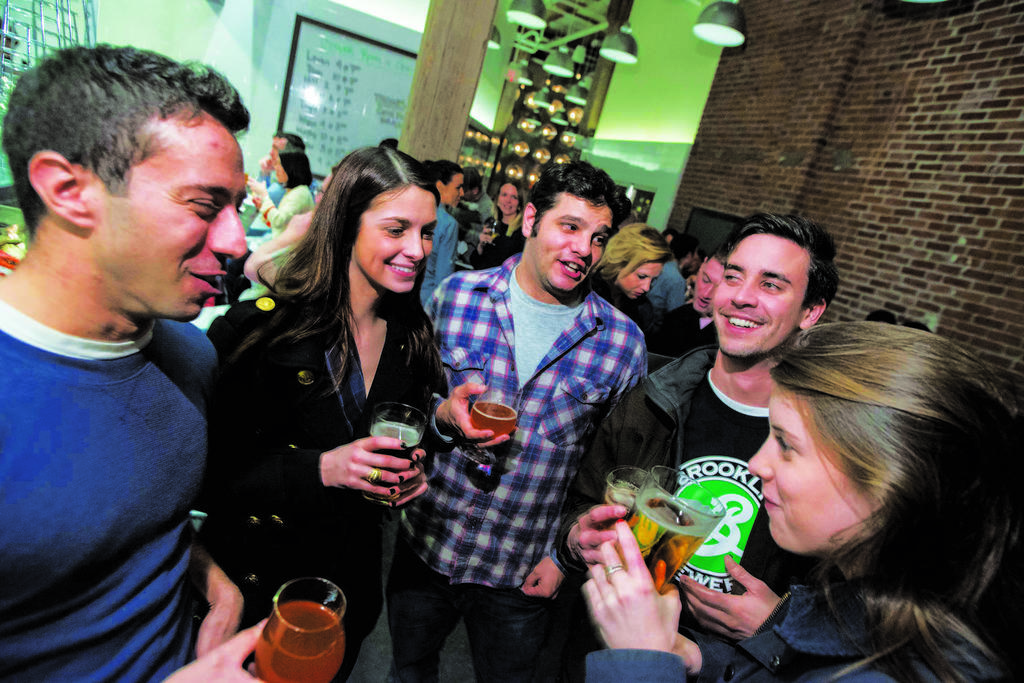What are the people in the image doing? The people in the image are standing and holding glasses. What expressions do the people have? The people are smiling. What can be seen in the background of the image? There is a wall, a light, a board, and a window in the background of the image. Are there any other people visible in the image? Yes, there are additional people standing in the background of the image. What type of bat can be seen flying in the image? There is no bat present in the image. Are there any cacti visible in the image? There are no cacti visible in the image. 